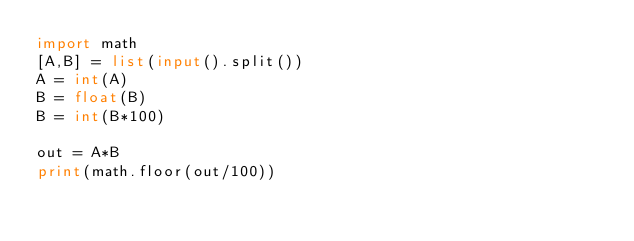<code> <loc_0><loc_0><loc_500><loc_500><_Python_>import math
[A,B] = list(input().split())
A = int(A)
B = float(B)
B = int(B*100)

out = A*B
print(math.floor(out/100))</code> 